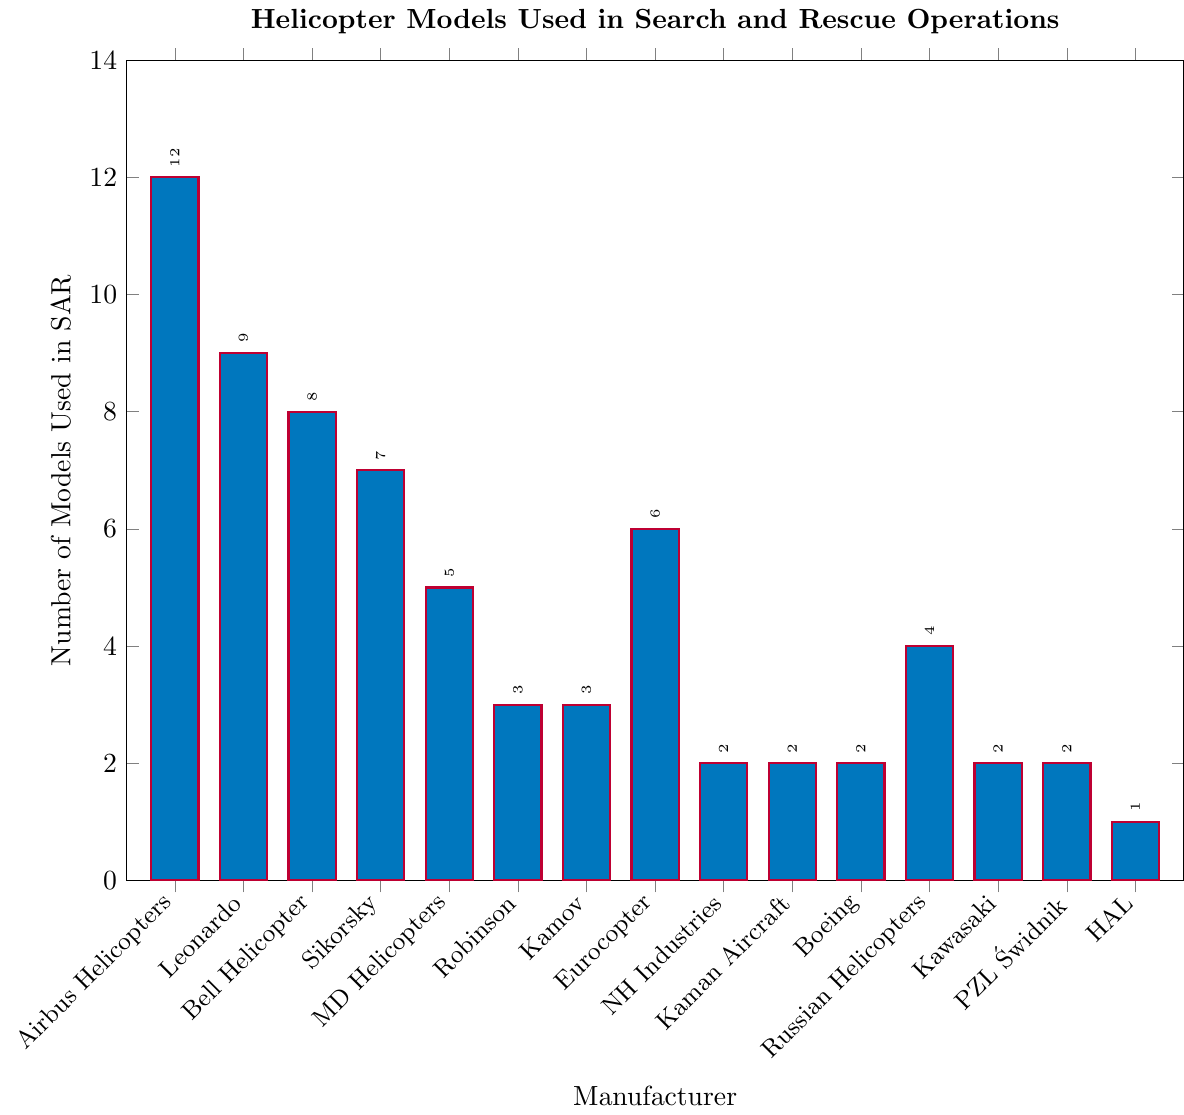Which manufacturer has the highest number of helicopter models used in search and rescue operations? Look at the height of each bar in the figure to determine which one is the highest. The highest bar represents Airbus Helicopters with 12 models.
Answer: Airbus Helicopters What is the difference in the number of models between Bell Helicopter and Russian Helicopters? Bell Helicopter has 8 models, and Russian Helicopters have 4 models. Calculate the difference by subtracting the smaller number from the larger one: 8 - 4 = 4.
Answer: 4 How many helicopter models are used by Kamov and Robinson Helicopter Company combined? Kamov has 3 models, and Robinson Helicopter Company has 3 models. Add the numbers together: 3 + 3 = 6.
Answer: 6 Which manufacturers have an equal number of helicopter models used in search and rescue operations? Look for bars with the same height. Robinson Helicopter Company and Kamov each have 3 models. NH Industries, Kaman Aircraft, Boeing, and Kawasaki all have 2 models each.
Answer: Robinson Helicopter Company and Kamov; NH Industries, Kaman Aircraft, Boeing, and Kawasaki Compare the number of models used by MD Helicopters and Sikorsky. Which one has more? MD Helicopters has 5 models, while Sikorsky has 7 models. Sikorsky has more.
Answer: Sikorsky What is the total number of helicopter models used by manufacturers with 2 models each? Sum the number of models from NH Industries (2), Kaman Aircraft (2), Boeing (2), Kawasaki (2), and PZL Świdnik (2): 2 + 2 + 2 + 2 + 2 = 10.
Answer: 10 What's the sum of helicopter models used by Airbus Helicopters, Leonardo, and MD Helicopters? Airbus Helicopters have 12 models, Leonardo has 9, and MD Helicopters have 5. Adding them together: 12 + 9 + 5 = 26.
Answer: 26 Which manufacturer has the fewest helicopter models used in search and rescue operations? The shortest bar in the figure represents the manufacturer with the fewest models. HAL has the shortest bar with 1 model.
Answer: HAL 